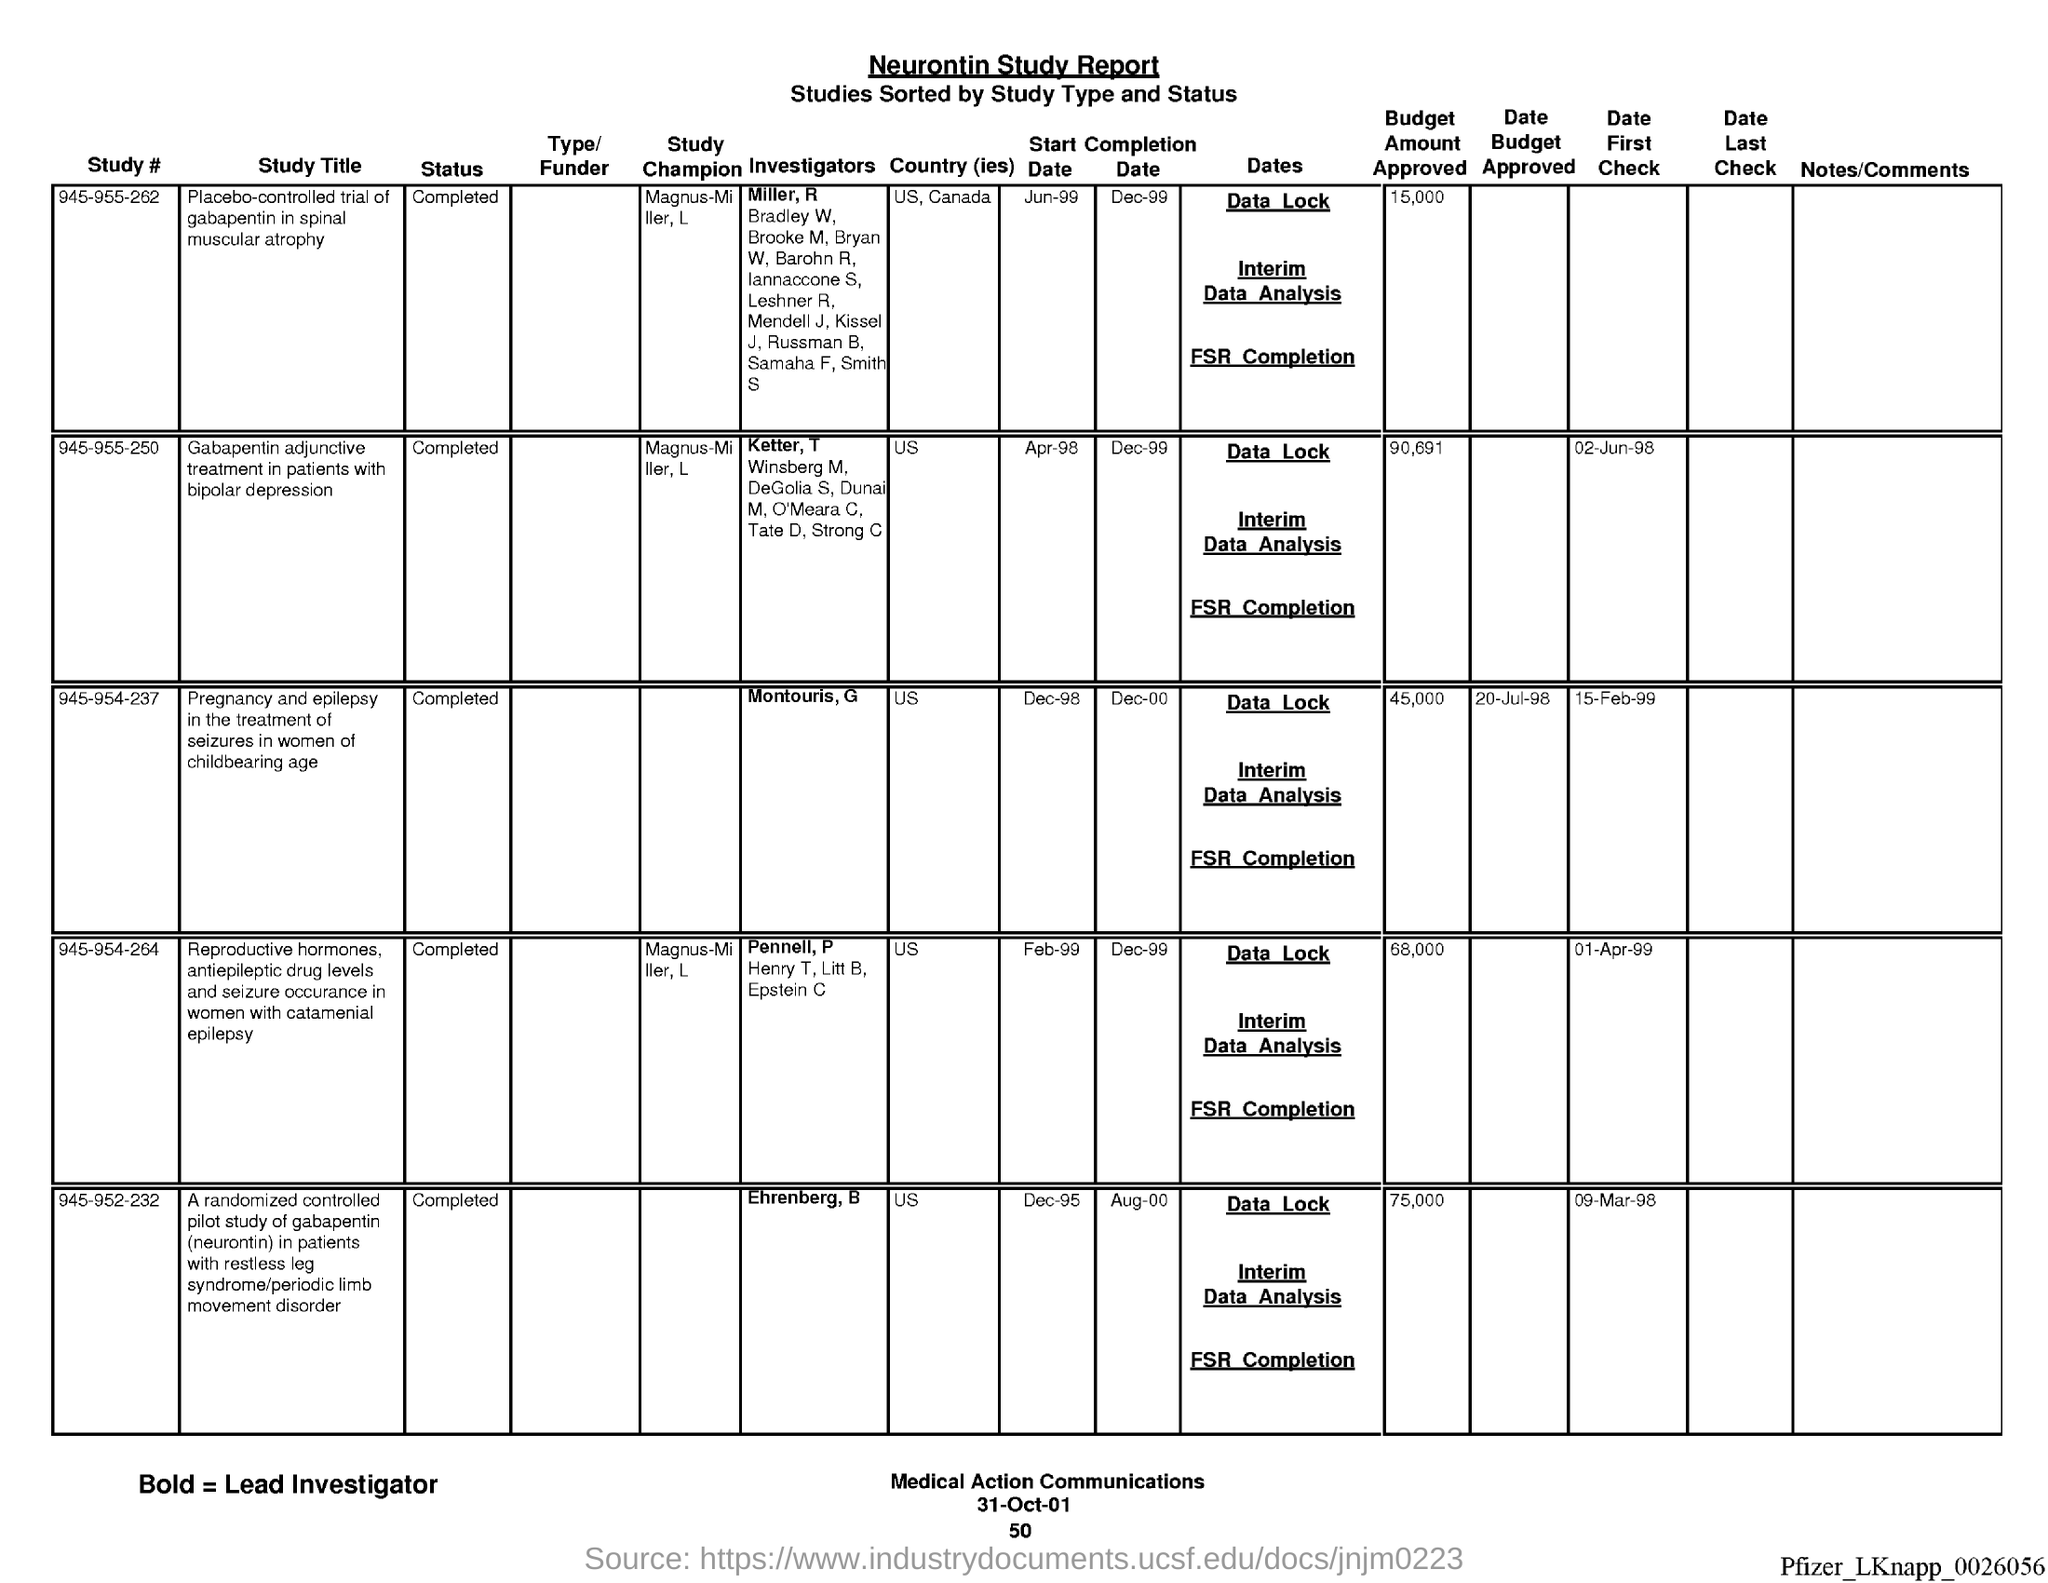What is the Status of study # 945-955-262?
Keep it short and to the point. Completed. What is the Status of study # 945-955-250?
Offer a very short reply. Completed. What is the Status of study # 945-954-237?
Provide a succinct answer. Completed. What is the Status of study # 945-964-264?
Ensure brevity in your answer.  Completed. What is the Status of study # 945-952-232?
Provide a short and direct response. Completed. What is the Country of study # 945-955-262?
Provide a succinct answer. US, Canada. What is the Country of study # 945-955-250?
Your answer should be very brief. Us. What is the Country of study # 945-954-237?
Make the answer very short. Us. What is the Country of study # 945-964-264?
Offer a very short reply. US. What is the Country of study # 945-952-232?
Provide a succinct answer. US. 